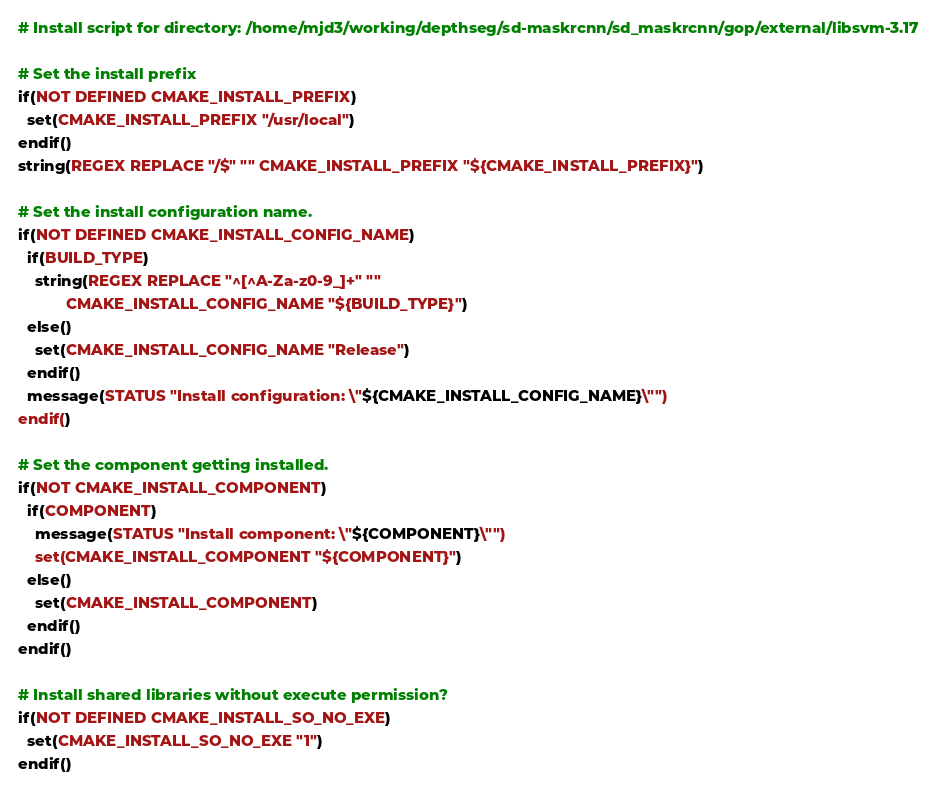<code> <loc_0><loc_0><loc_500><loc_500><_CMake_># Install script for directory: /home/mjd3/working/depthseg/sd-maskrcnn/sd_maskrcnn/gop/external/libsvm-3.17

# Set the install prefix
if(NOT DEFINED CMAKE_INSTALL_PREFIX)
  set(CMAKE_INSTALL_PREFIX "/usr/local")
endif()
string(REGEX REPLACE "/$" "" CMAKE_INSTALL_PREFIX "${CMAKE_INSTALL_PREFIX}")

# Set the install configuration name.
if(NOT DEFINED CMAKE_INSTALL_CONFIG_NAME)
  if(BUILD_TYPE)
    string(REGEX REPLACE "^[^A-Za-z0-9_]+" ""
           CMAKE_INSTALL_CONFIG_NAME "${BUILD_TYPE}")
  else()
    set(CMAKE_INSTALL_CONFIG_NAME "Release")
  endif()
  message(STATUS "Install configuration: \"${CMAKE_INSTALL_CONFIG_NAME}\"")
endif()

# Set the component getting installed.
if(NOT CMAKE_INSTALL_COMPONENT)
  if(COMPONENT)
    message(STATUS "Install component: \"${COMPONENT}\"")
    set(CMAKE_INSTALL_COMPONENT "${COMPONENT}")
  else()
    set(CMAKE_INSTALL_COMPONENT)
  endif()
endif()

# Install shared libraries without execute permission?
if(NOT DEFINED CMAKE_INSTALL_SO_NO_EXE)
  set(CMAKE_INSTALL_SO_NO_EXE "1")
endif()

</code> 